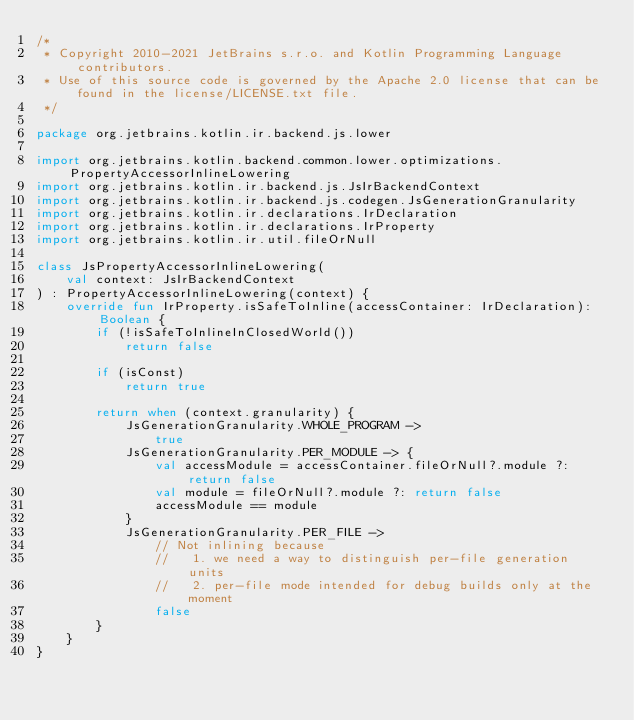<code> <loc_0><loc_0><loc_500><loc_500><_Kotlin_>/*
 * Copyright 2010-2021 JetBrains s.r.o. and Kotlin Programming Language contributors.
 * Use of this source code is governed by the Apache 2.0 license that can be found in the license/LICENSE.txt file.
 */

package org.jetbrains.kotlin.ir.backend.js.lower

import org.jetbrains.kotlin.backend.common.lower.optimizations.PropertyAccessorInlineLowering
import org.jetbrains.kotlin.ir.backend.js.JsIrBackendContext
import org.jetbrains.kotlin.ir.backend.js.codegen.JsGenerationGranularity
import org.jetbrains.kotlin.ir.declarations.IrDeclaration
import org.jetbrains.kotlin.ir.declarations.IrProperty
import org.jetbrains.kotlin.ir.util.fileOrNull

class JsPropertyAccessorInlineLowering(
    val context: JsIrBackendContext
) : PropertyAccessorInlineLowering(context) {
    override fun IrProperty.isSafeToInline(accessContainer: IrDeclaration): Boolean {
        if (!isSafeToInlineInClosedWorld())
            return false

        if (isConst)
            return true

        return when (context.granularity) {
            JsGenerationGranularity.WHOLE_PROGRAM ->
                true
            JsGenerationGranularity.PER_MODULE -> {
                val accessModule = accessContainer.fileOrNull?.module ?: return false
                val module = fileOrNull?.module ?: return false
                accessModule == module
            }
            JsGenerationGranularity.PER_FILE ->
                // Not inlining because
                //   1. we need a way to distinguish per-file generation units
                //   2. per-file mode intended for debug builds only at the moment
                false
        }
    }
}</code> 